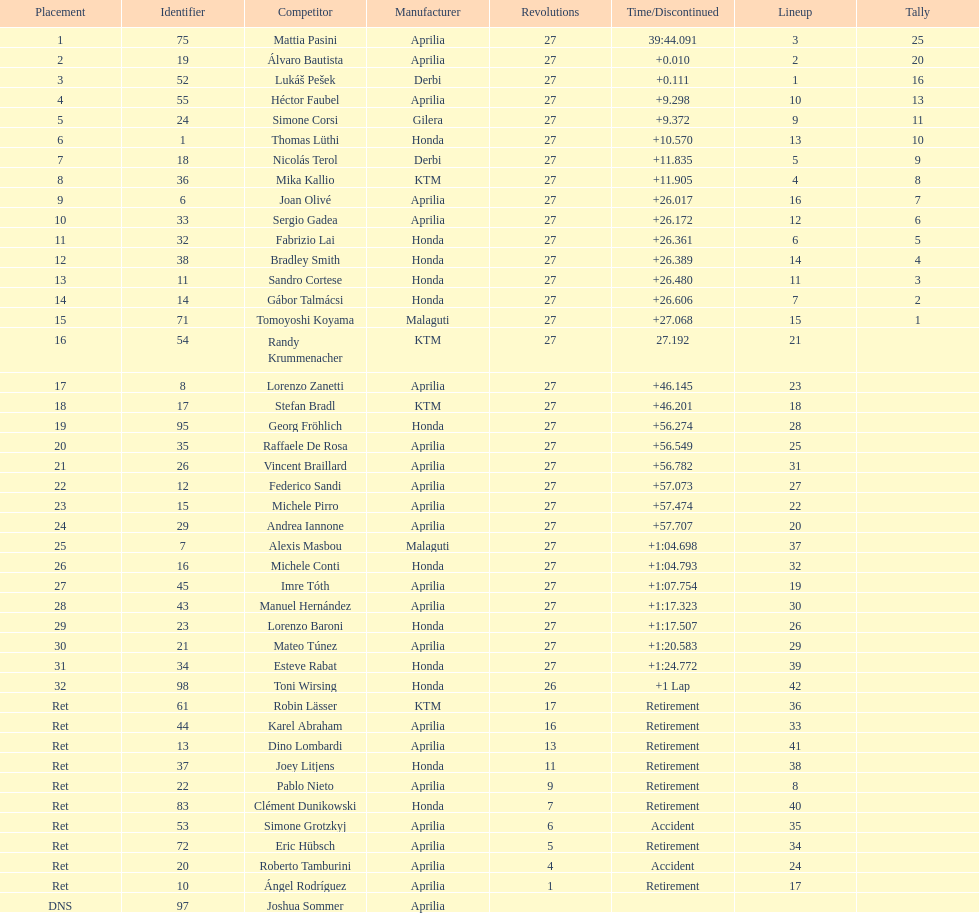Which rider came in first with 25 points? Mattia Pasini. 